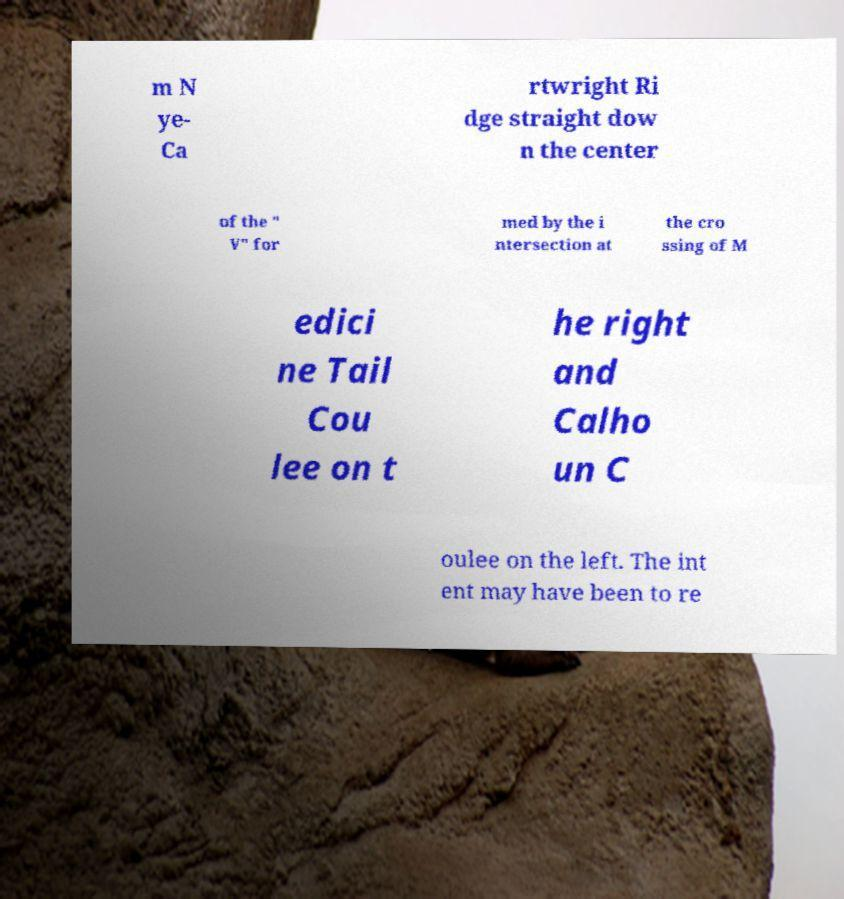Could you extract and type out the text from this image? m N ye- Ca rtwright Ri dge straight dow n the center of the " V" for med by the i ntersection at the cro ssing of M edici ne Tail Cou lee on t he right and Calho un C oulee on the left. The int ent may have been to re 